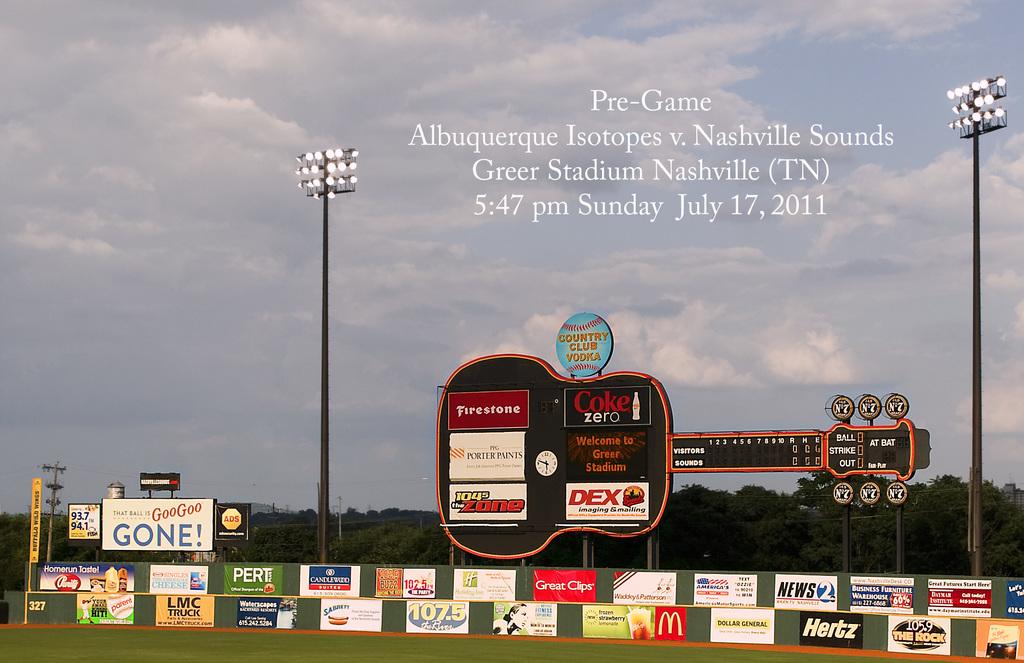When did this pre-game event take place?
Your answer should be compact. July 17, 2011. What time did it take place?
Make the answer very short. 5:47 pm. 